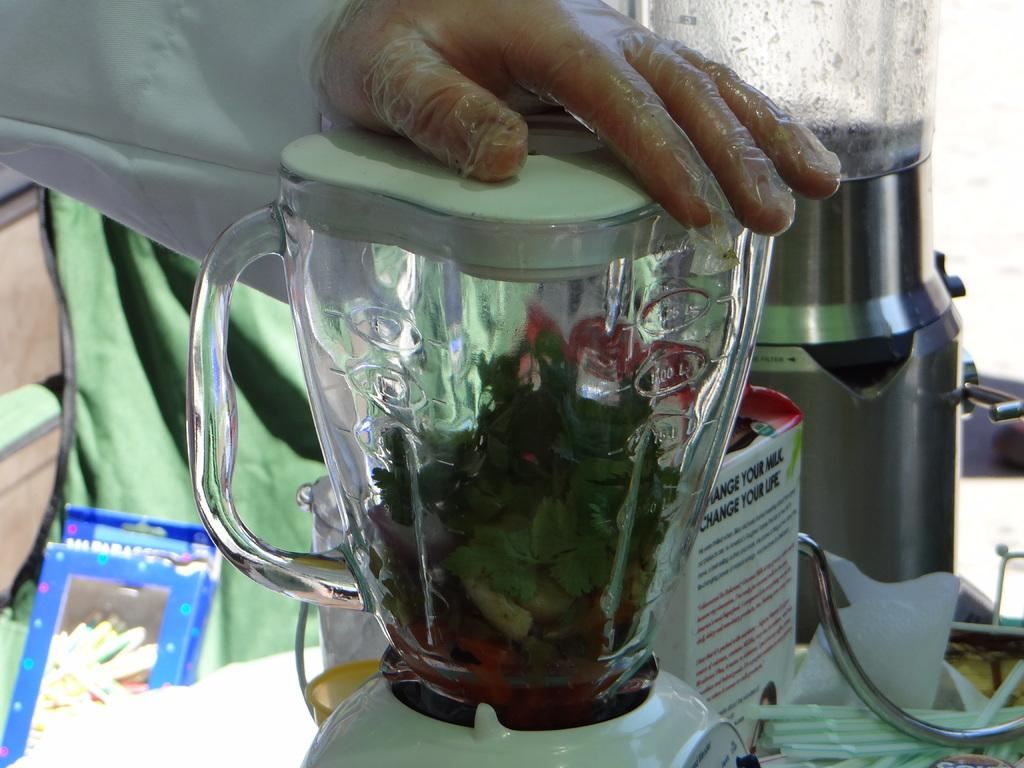<image>
Provide a brief description of the given image. A carton next to a blender which reads 'change your milk, change your life.' 